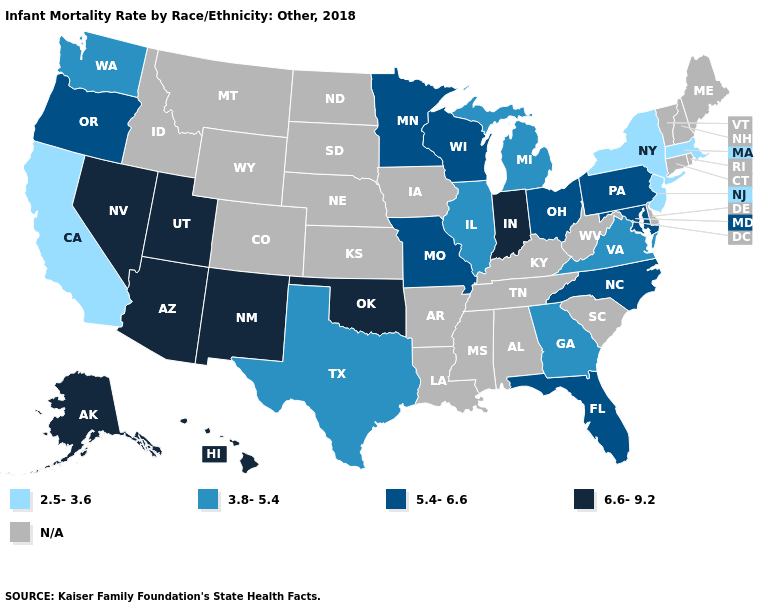What is the value of Illinois?
Answer briefly. 3.8-5.4. Name the states that have a value in the range 3.8-5.4?
Be succinct. Georgia, Illinois, Michigan, Texas, Virginia, Washington. What is the highest value in the West ?
Give a very brief answer. 6.6-9.2. What is the value of New York?
Be succinct. 2.5-3.6. What is the value of Vermont?
Answer briefly. N/A. Name the states that have a value in the range 3.8-5.4?
Answer briefly. Georgia, Illinois, Michigan, Texas, Virginia, Washington. Among the states that border New Jersey , which have the lowest value?
Be succinct. New York. Among the states that border Wisconsin , does Michigan have the lowest value?
Concise answer only. Yes. Among the states that border Michigan , which have the lowest value?
Concise answer only. Ohio, Wisconsin. Name the states that have a value in the range 3.8-5.4?
Write a very short answer. Georgia, Illinois, Michigan, Texas, Virginia, Washington. Does the map have missing data?
Concise answer only. Yes. Name the states that have a value in the range 6.6-9.2?
Be succinct. Alaska, Arizona, Hawaii, Indiana, Nevada, New Mexico, Oklahoma, Utah. What is the value of Hawaii?
Be succinct. 6.6-9.2. Among the states that border Pennsylvania , which have the lowest value?
Be succinct. New Jersey, New York. 